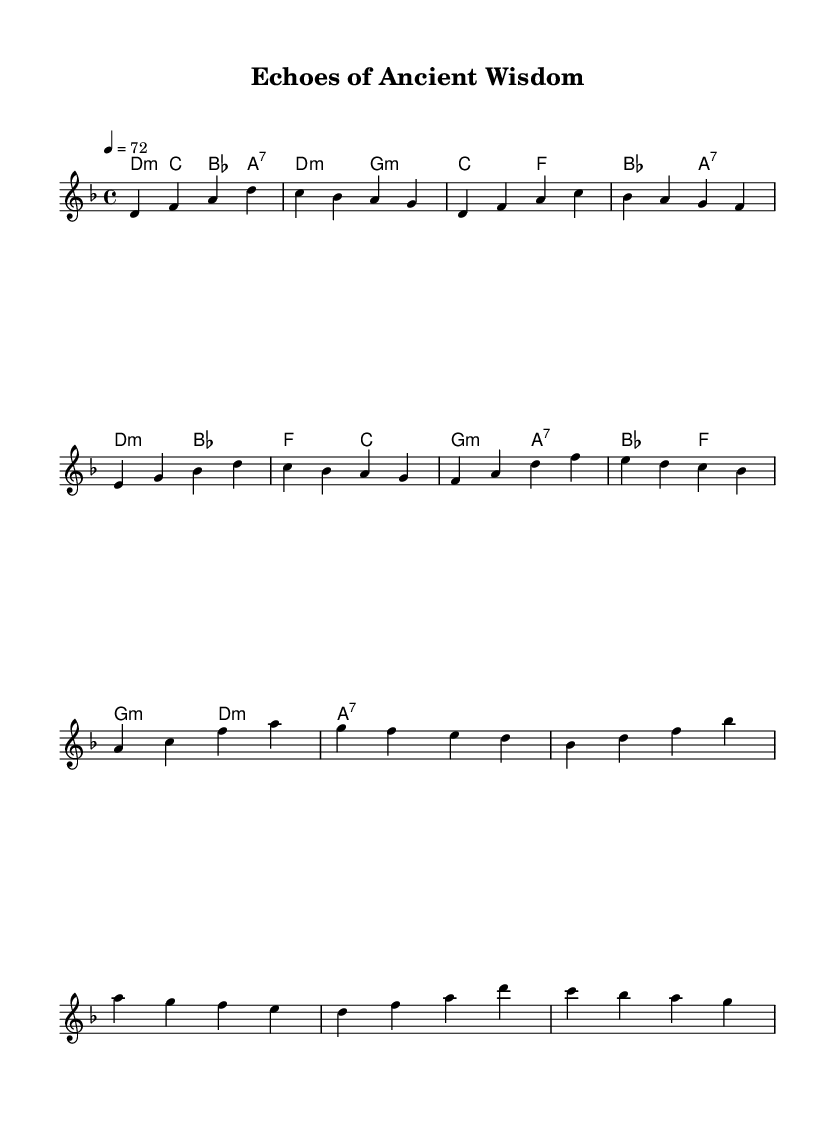What is the key signature of this music? The key signature indicated in the global section of the sheet music is D minor, which includes one flat.
Answer: D minor What is the time signature of the piece? The time signature, as shown in the global section, is 4/4, meaning there are four beats per measure.
Answer: 4/4 What is the tempo marking for this piece? The tempo is set to 72 beats per minute, as indicated in the global section.
Answer: 72 How many measures are present in the verse? The verse consists of four measures, as can be counted in the score section.
Answer: 4 Which chord appears at the beginning of the chorus? The first chord of the chorus is D minor, found in the chord representation of the score.
Answer: D minor What is the relationship of the bridge to the other sections? The bridge introduces a contrasting section that connects the chorus back to the verse, usually providing tension and resolution.
Answer: Contrast What type of music structure does this piece demonstrate? The music follows a common pop structure with verses and a chorus, reflecting typical pop ballad arrangements.
Answer: Verse-Chorus 